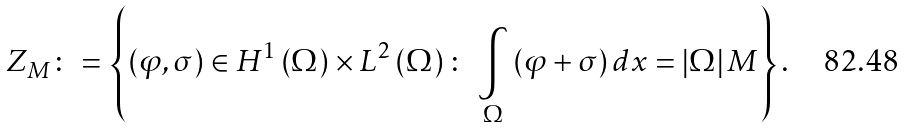<formula> <loc_0><loc_0><loc_500><loc_500>Z _ { M } \colon = \left \{ \left ( \varphi , \sigma \right ) \in H ^ { 1 } \left ( \Omega \right ) \times L ^ { 2 } \left ( \Omega \right ) \colon \text { } \underset { \Omega } { \int } \left ( \varphi + \sigma \right ) d x = \left | \Omega \right | M \right \} \text {.}</formula> 